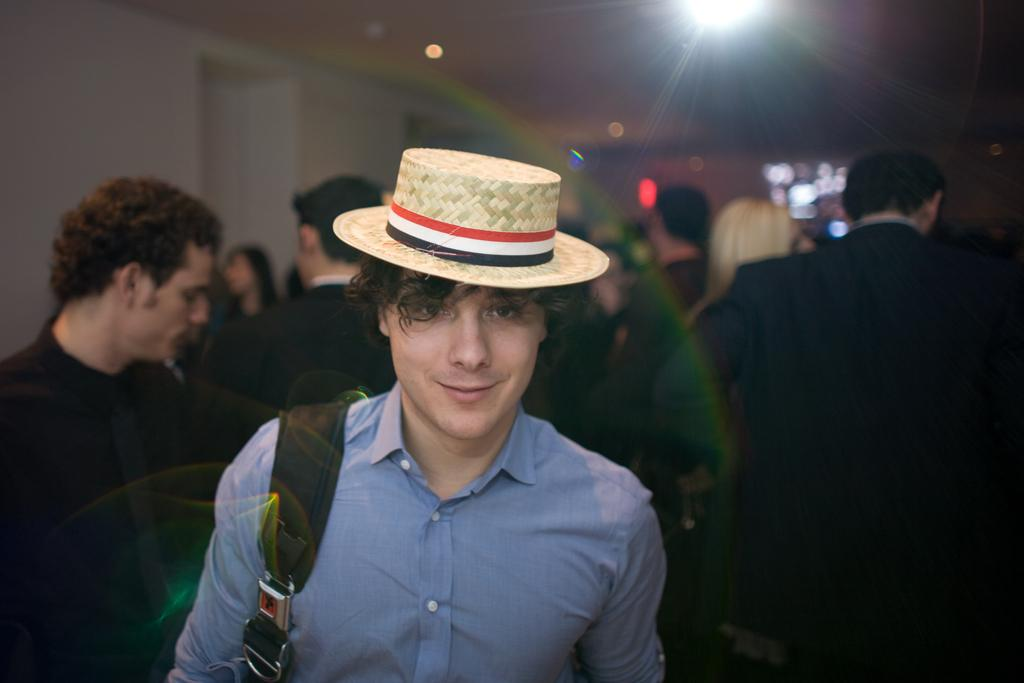What is the main subject of the image? There is a man standing in the middle of the image. What is the man's facial expression? The man is smiling. Are there any other people in the image? Yes, there are people standing behind the man. What type of structure is visible at the top of the image? There is a wall and roof visible at the top of the image. What can be seen illuminating the area at the top of the image? Lights are present at the top of the image. What type of quarter is being used to draw on the man's face in the image? There is no quarter or drawing on the man's face in the image; he is simply smiling. What color is the ink used to draw on the man's face in the image? There is no ink or drawing on the man's face in the image; he is simply smiling. 